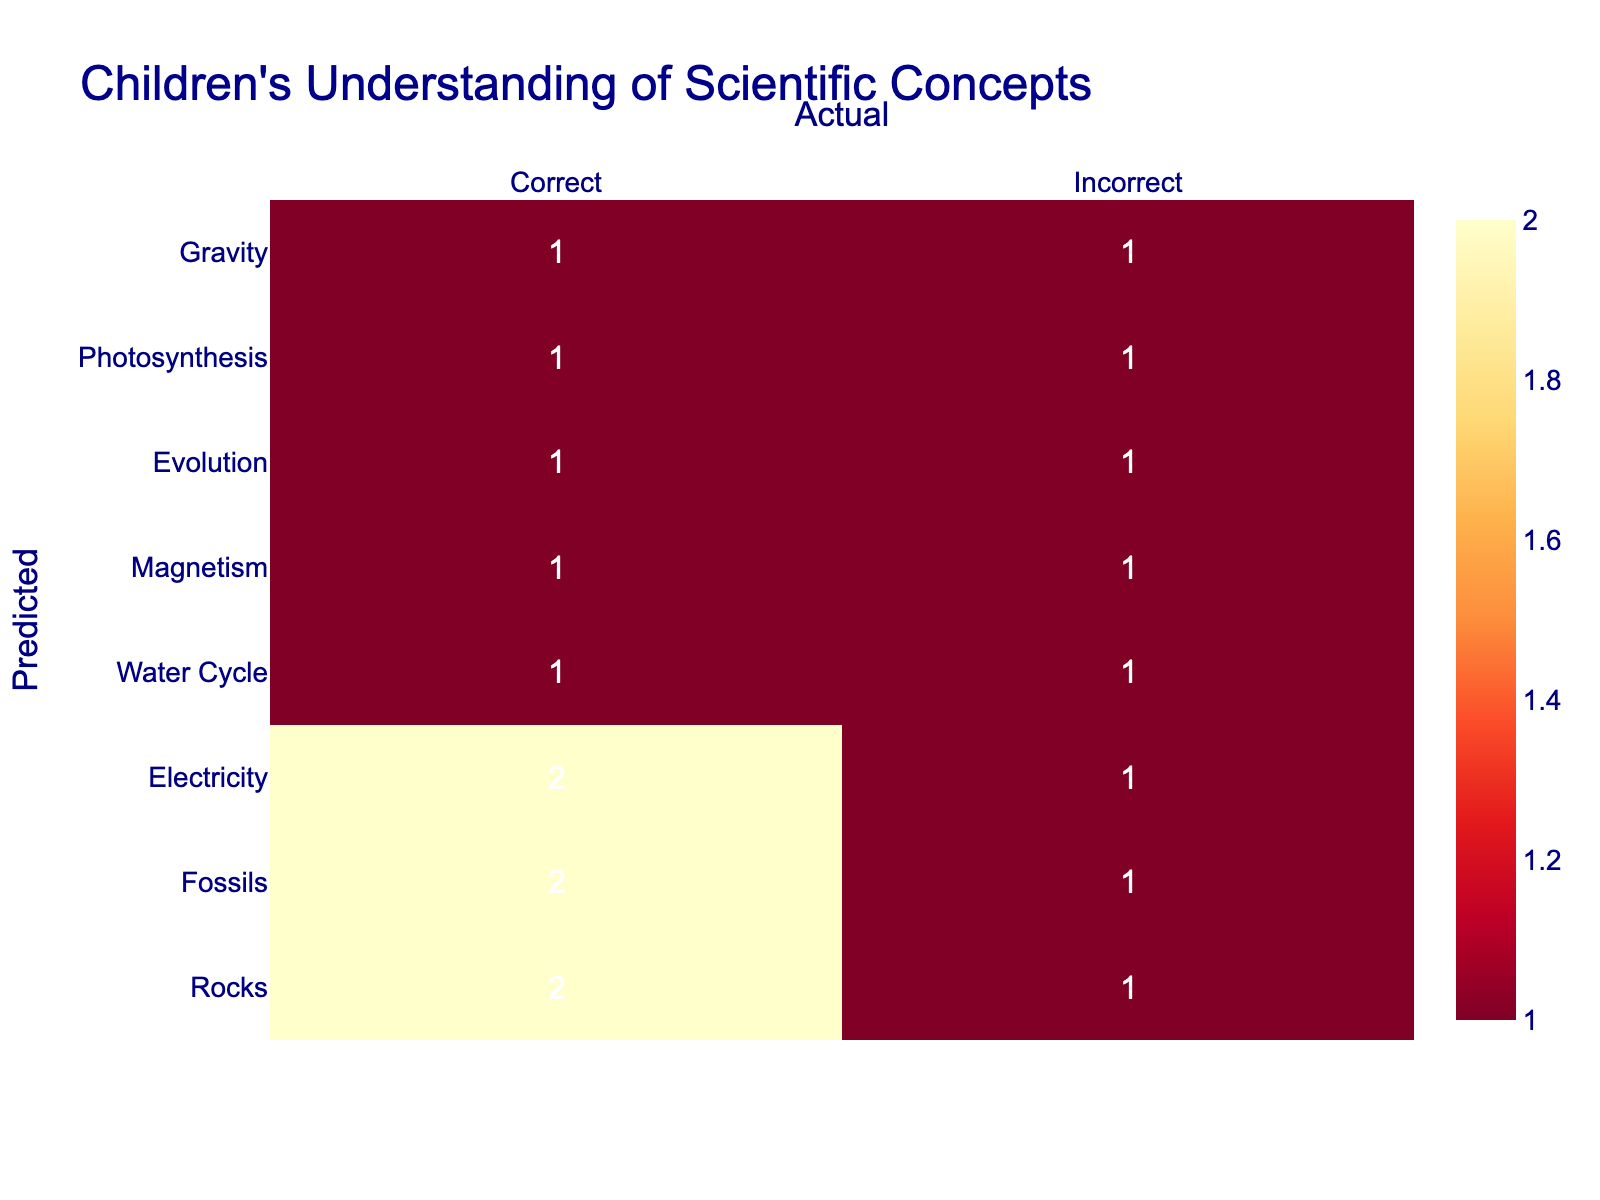What is the number of correct responses for the concept of Gravity? From the table, we can find the row for "Gravity" and see that there is 1 correct response listed under it.
Answer: 1 How many incorrect responses were recorded for Photosynthesis? Checking the row for "Photosynthesis," there is 1 incorrect response listed under it, so the total is 1.
Answer: 1 What is the total number of responses for the concept of Rocks? Looking at the information for "Rocks," we note that there are 3 responses: 2 correct and 1 incorrect. So the total is 2 + 1 = 3.
Answer: 3 Is there a higher number of correct responses for Electricity than for Magnetism? By comparing the two concepts, "Electricity" has 1 correct response while "Magnetism" has 1 correct response as well. Since both are equal, the answer to the question is no.
Answer: No How many total responses were correct across all concepts? To find the total number of correct responses, we add all the correct counts from each concept: 1 (Gravity) + 2 (Photosynthesis) + 1 (Evolution) + 1 (Magnetism) + 2 (Water Cycle) + 1 (Electricity) + 1 (Fossils) + 2 (Rocks) = 11.
Answer: 11 Which scientific concept had the highest number of incorrect responses? To determine the concept with the highest incorrect responses, we check each concept's incorrect count: Gravity (1), Photosynthesis (1), Evolution (1), Magnetism (1), Water Cycle (1), Electricity (1), Fossils (1), Rocks (1). All have the same count of 1 incorrect response, leading to no single winner.
Answer: None What is the difference in the number of correct versus incorrect responses for Fossils? Analyzing the "Fossils" row, there are 1 correct and 1 incorrect response, yielding a difference of 1 - 1 = 0, so the result is zero difference.
Answer: 0 What percentage of responses for the Water Cycle were correct? Total responses for "Water Cycle" are 2 correct and 1 incorrect, giving a total of 2 + 1 = 3 responses. The percentage of correct responses is (2/3) * 100 which is approximately 66.67%.
Answer: 66.67% How many total incorrect responses were there in the table? To find the total number of incorrect responses, we sum up all the incorrect counts: 1 (Gravity) + 1 (Photosynthesis) + 1 (Evolution) + 1 (Magnetism) + 1 (Water Cycle) + 1 (Electricity) + 1 (Fossils) + 1 (Rocks) = 8 total incorrect responses.
Answer: 8 